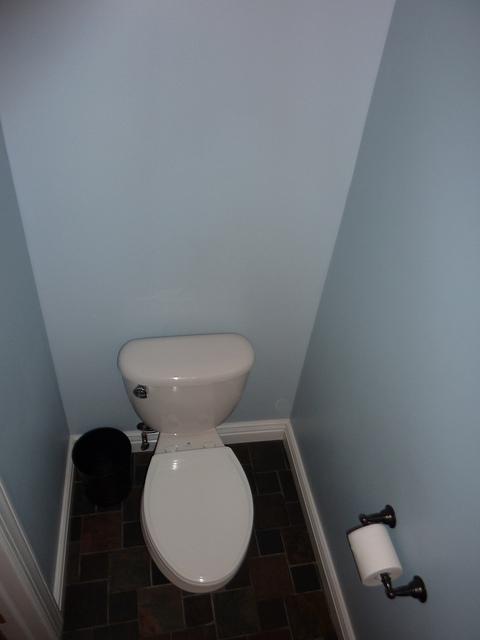How many rolls of toilet paper are in the picture?
Give a very brief answer. 1. How many chairs are around the table?
Give a very brief answer. 0. 